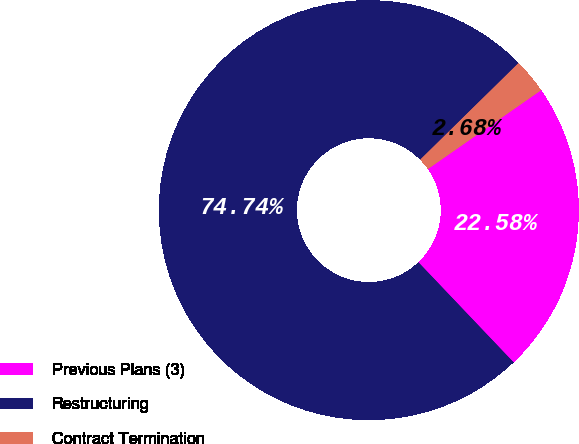Convert chart to OTSL. <chart><loc_0><loc_0><loc_500><loc_500><pie_chart><fcel>Previous Plans (3)<fcel>Restructuring<fcel>Contract Termination<nl><fcel>22.58%<fcel>74.74%<fcel>2.68%<nl></chart> 